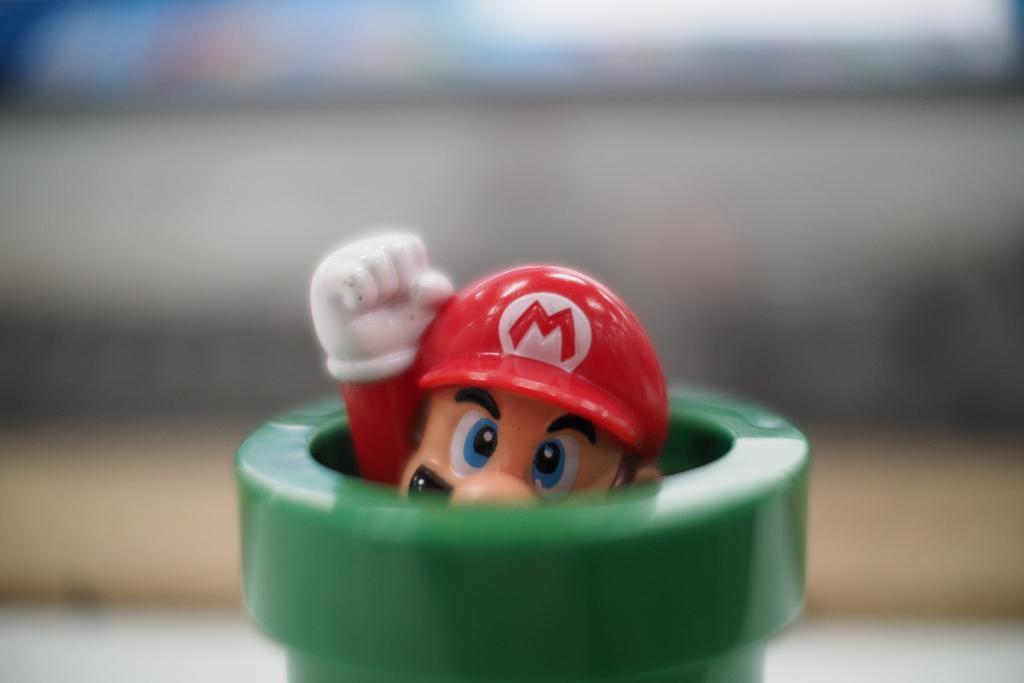How would you summarize this image in a sentence or two? In this picture we can see a toy and blurry background. 